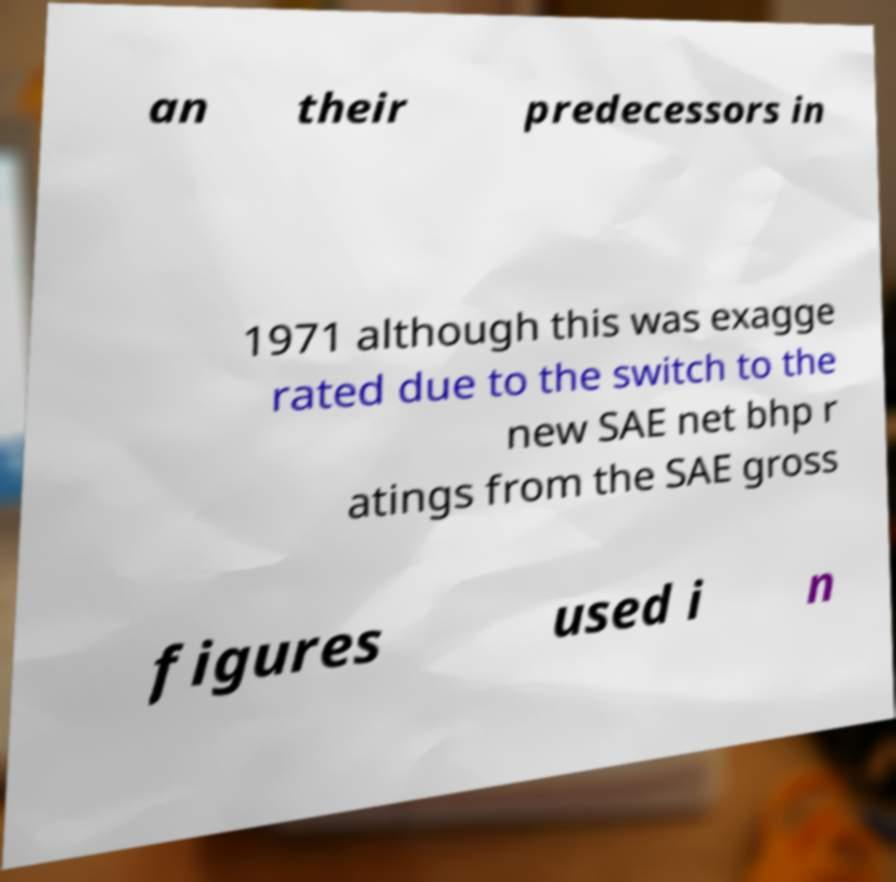I need the written content from this picture converted into text. Can you do that? an their predecessors in 1971 although this was exagge rated due to the switch to the new SAE net bhp r atings from the SAE gross figures used i n 